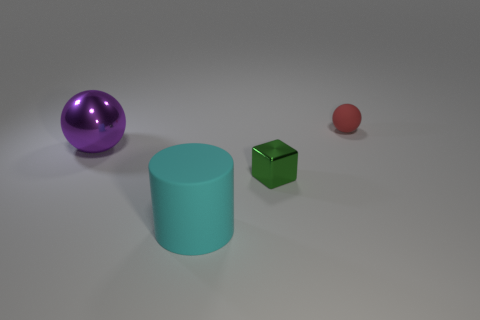How many balls are on the right side of the large rubber object and left of the small rubber sphere?
Make the answer very short. 0. Are there fewer metal objects in front of the large cyan matte cylinder than big purple shiny balls?
Ensure brevity in your answer.  Yes. Are there any green blocks of the same size as the red rubber thing?
Give a very brief answer. Yes. What color is the tiny object that is made of the same material as the big ball?
Offer a terse response. Green. There is a matte object behind the cyan rubber object; how many red rubber spheres are on the right side of it?
Provide a succinct answer. 0. There is a thing that is in front of the big metallic ball and behind the matte cylinder; what material is it?
Your answer should be compact. Metal. Do the metal object that is in front of the metal ball and the large cyan matte object have the same shape?
Offer a terse response. No. Are there fewer big purple metal things than small blue matte spheres?
Make the answer very short. No. What number of matte objects have the same color as the big shiny thing?
Offer a very short reply. 0. There is a tiny cube; does it have the same color as the sphere in front of the red matte object?
Your response must be concise. No. 